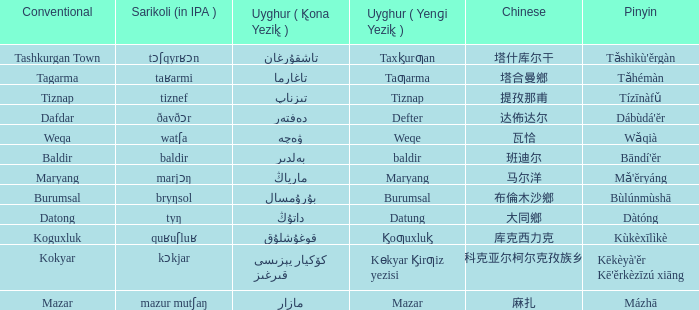Can you provide the pinyin version of the word mazar? Mázhā. 